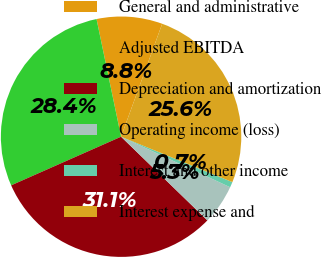Convert chart to OTSL. <chart><loc_0><loc_0><loc_500><loc_500><pie_chart><fcel>General and administrative<fcel>Adjusted EBITDA<fcel>Depreciation and amortization<fcel>Operating income (loss)<fcel>Interest and other income<fcel>Interest expense and<nl><fcel>8.83%<fcel>28.36%<fcel>31.12%<fcel>5.35%<fcel>0.74%<fcel>25.61%<nl></chart> 